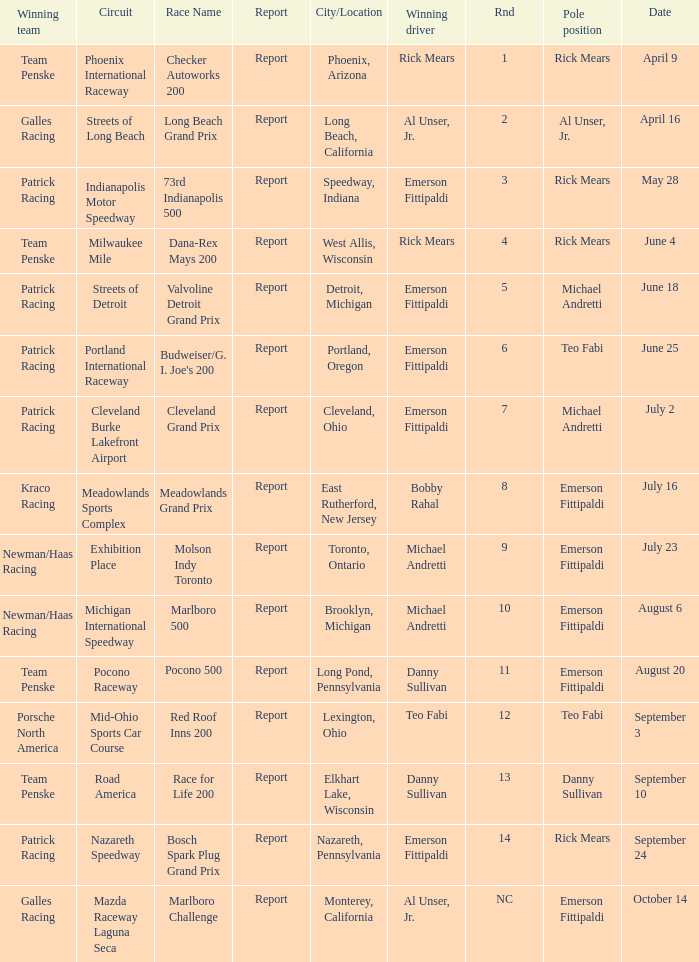What rnds were there for the phoenix international raceway? 1.0. 